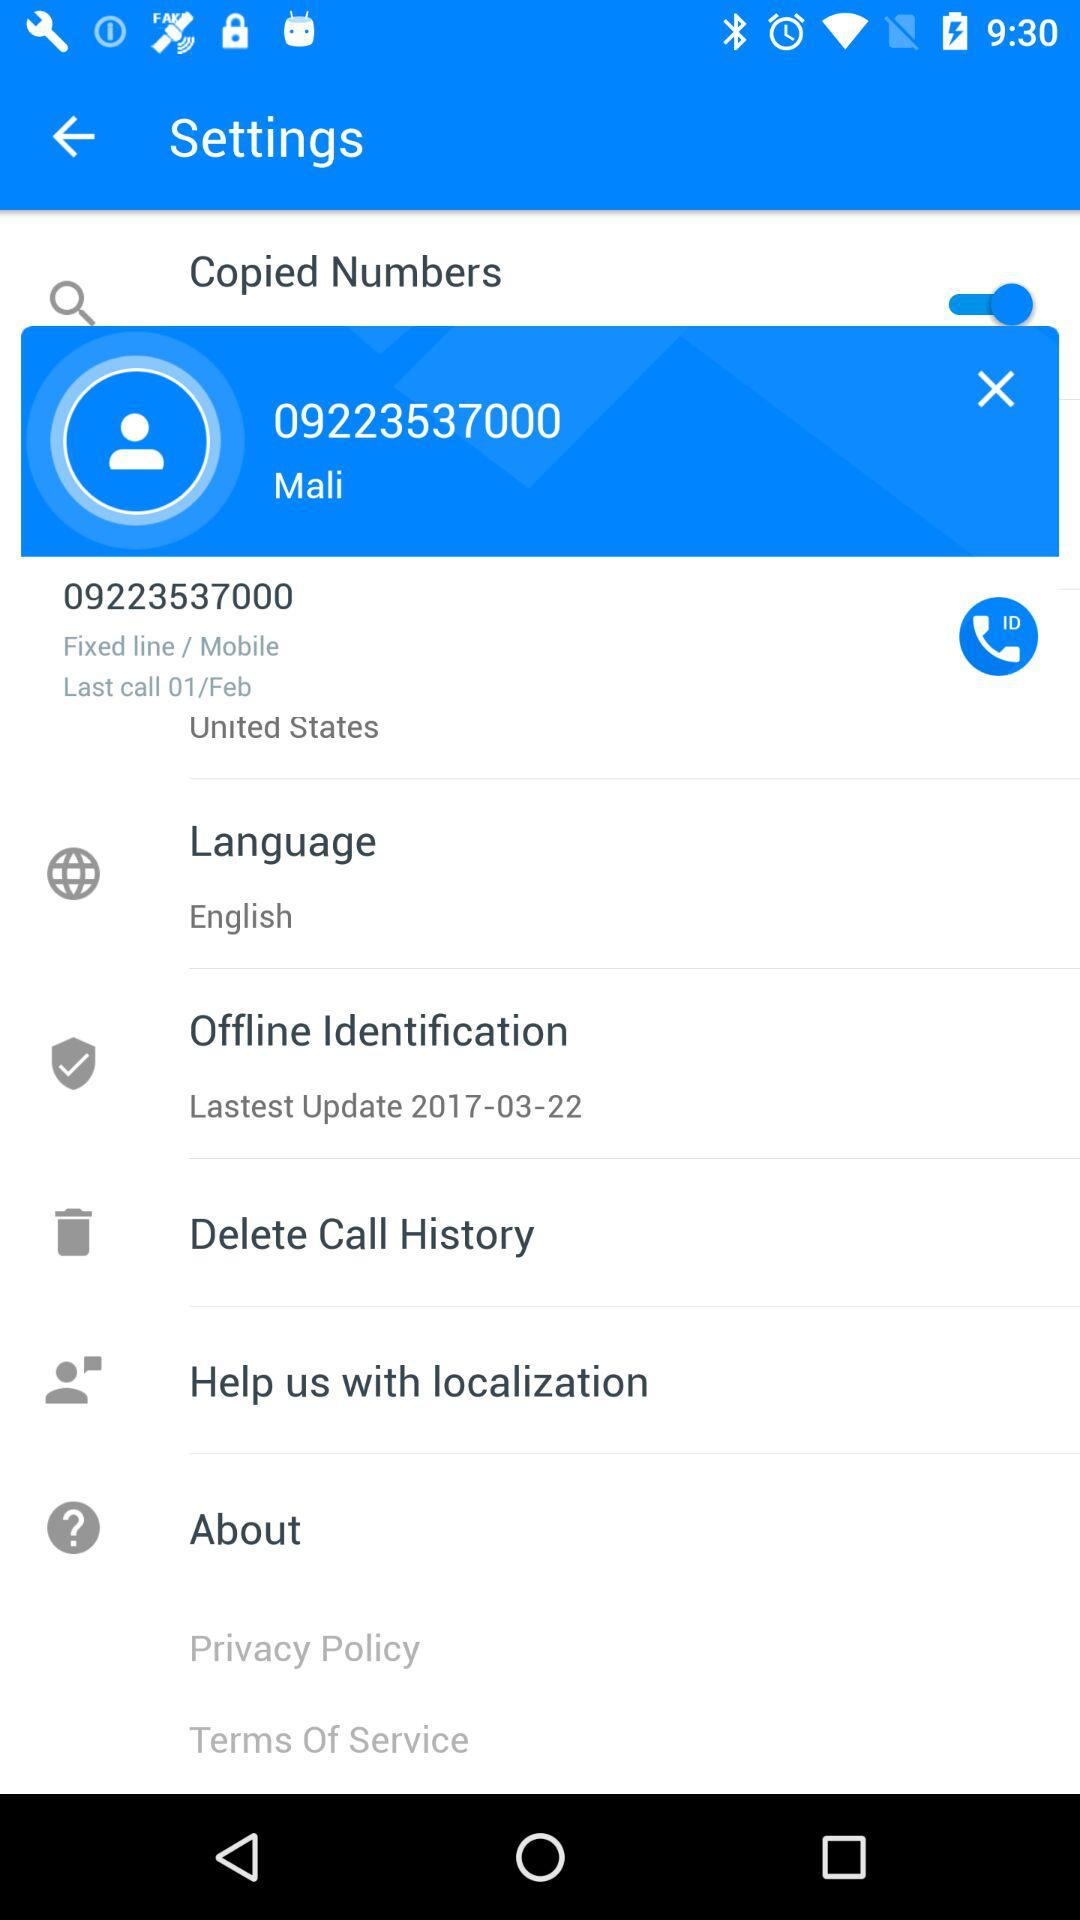Which language is chosen? The chosen language is English. 